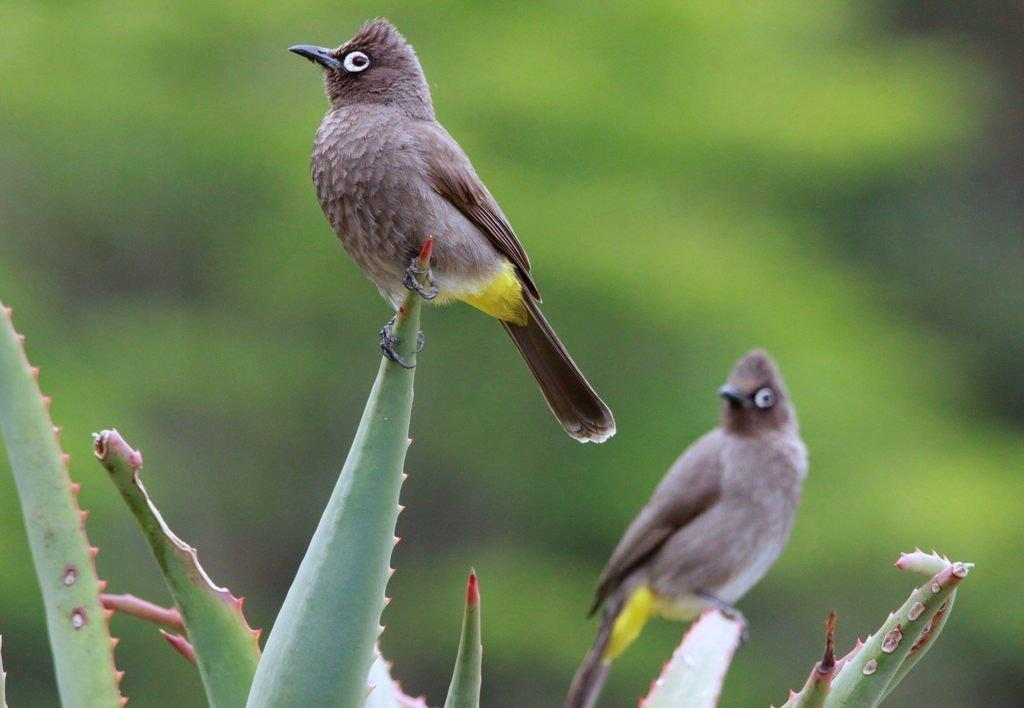How many birds can be seen in the image? There are two birds visible in the image. What are the birds perched on? The birds are on an aloe vera plant. What color is the background of the image? The background of the image is green. Can you see a frog wearing a ring in the image? No, there is no frog or ring present in the image. 